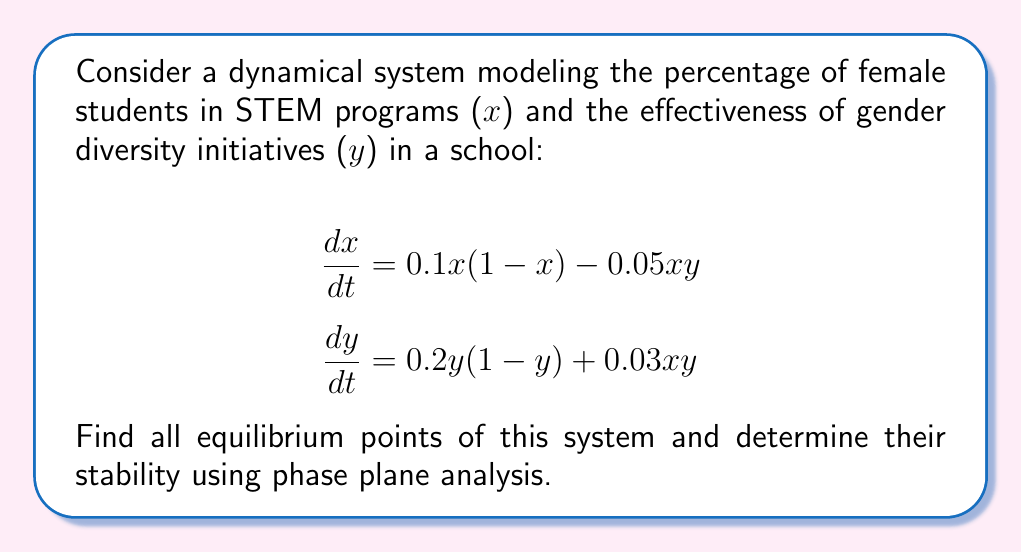Give your solution to this math problem. 1) To find equilibrium points, set both equations to zero:

   $$0.1x(1-x) - 0.05xy = 0$$
   $$0.2y(1-y) + 0.03xy = 0$$

2) From the first equation:
   $$x(0.1 - 0.1x - 0.05y) = 0$$
   So, $x = 0$ or $0.1 - 0.1x - 0.05y = 0$

3) From the second equation:
   $$y(0.2 - 0.2y + 0.03x) = 0$$
   So, $y = 0$ or $0.2 - 0.2y + 0.03x = 0$

4) Combining these, we get four potential equilibrium points:
   (0,0), (1,0), (0,1), and the intersection of the two lines.

5) For the intersection point, solve:
   $$0.1 - 0.1x - 0.05y = 0$$
   $$0.2 - 0.2y + 0.03x = 0$$
   
   This gives $(x,y) = (0.6316, 0.7368)$

6) To determine stability, we need to find the Jacobian matrix:

   $$J = \begin{bmatrix}
   0.1 - 0.2x - 0.05y & -0.05x \\
   0.03y & 0.2 - 0.4y + 0.03x
   \end{bmatrix}$$

7) Evaluate J at each equilibrium point and find eigenvalues:

   At (0,0): $J = \begin{bmatrix} 0.1 & 0 \\ 0 & 0.2 \end{bmatrix}$
   Eigenvalues: 0.1 and 0.2 (both positive) - Unstable node

   At (1,0): $J = \begin{bmatrix} -0.1 & -0.05 \\ 0 & 0.23 \end{bmatrix}$
   Eigenvalues: -0.1 and 0.23 - Saddle point

   At (0,1): $J = \begin{bmatrix} 0.05 & 0 \\ 0.03 & -0.2 \end{bmatrix}$
   Eigenvalues: 0.05 and -0.2 - Saddle point

   At (0.6316, 0.7368): $J = \begin{bmatrix} -0.0632 & -0.0316 \\ 0.0221 & -0.0948 \end{bmatrix}$
   Eigenvalues: -0.0790 ± 0.0401i (both with negative real parts) - Stable spiral

8) The phase plane analysis reveals that (0.6316, 0.7368) is the only stable equilibrium point, representing a balance between female STEM participation and initiative effectiveness.
Answer: Four equilibrium points: (0,0) unstable node, (1,0) and (0,1) saddle points, (0.6316, 0.7368) stable spiral. 